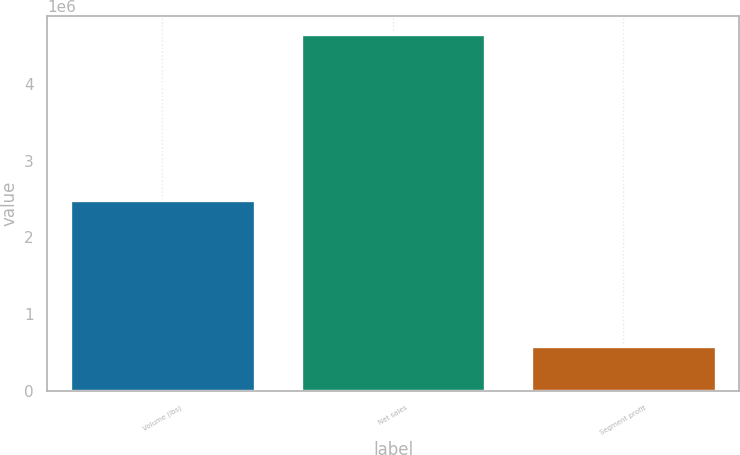Convert chart to OTSL. <chart><loc_0><loc_0><loc_500><loc_500><bar_chart><fcel>Volume (lbs)<fcel>Net sales<fcel>Segment profit<nl><fcel>2.49336e+06<fcel>4.64717e+06<fcel>585652<nl></chart> 